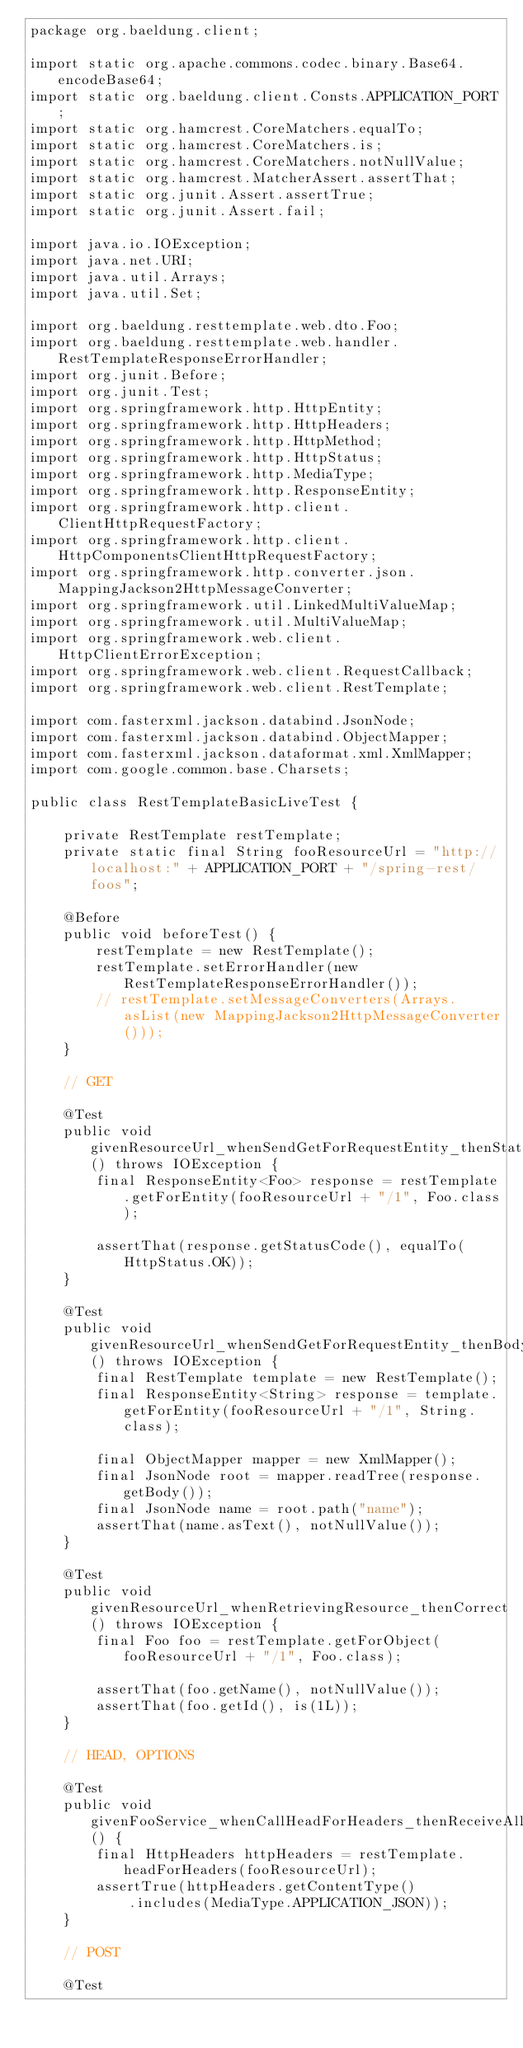<code> <loc_0><loc_0><loc_500><loc_500><_Java_>package org.baeldung.client;

import static org.apache.commons.codec.binary.Base64.encodeBase64;
import static org.baeldung.client.Consts.APPLICATION_PORT;
import static org.hamcrest.CoreMatchers.equalTo;
import static org.hamcrest.CoreMatchers.is;
import static org.hamcrest.CoreMatchers.notNullValue;
import static org.hamcrest.MatcherAssert.assertThat;
import static org.junit.Assert.assertTrue;
import static org.junit.Assert.fail;

import java.io.IOException;
import java.net.URI;
import java.util.Arrays;
import java.util.Set;

import org.baeldung.resttemplate.web.dto.Foo;
import org.baeldung.resttemplate.web.handler.RestTemplateResponseErrorHandler;
import org.junit.Before;
import org.junit.Test;
import org.springframework.http.HttpEntity;
import org.springframework.http.HttpHeaders;
import org.springframework.http.HttpMethod;
import org.springframework.http.HttpStatus;
import org.springframework.http.MediaType;
import org.springframework.http.ResponseEntity;
import org.springframework.http.client.ClientHttpRequestFactory;
import org.springframework.http.client.HttpComponentsClientHttpRequestFactory;
import org.springframework.http.converter.json.MappingJackson2HttpMessageConverter;
import org.springframework.util.LinkedMultiValueMap;
import org.springframework.util.MultiValueMap;
import org.springframework.web.client.HttpClientErrorException;
import org.springframework.web.client.RequestCallback;
import org.springframework.web.client.RestTemplate;

import com.fasterxml.jackson.databind.JsonNode;
import com.fasterxml.jackson.databind.ObjectMapper;
import com.fasterxml.jackson.dataformat.xml.XmlMapper;
import com.google.common.base.Charsets;

public class RestTemplateBasicLiveTest {

    private RestTemplate restTemplate;
    private static final String fooResourceUrl = "http://localhost:" + APPLICATION_PORT + "/spring-rest/foos";

    @Before
    public void beforeTest() {
        restTemplate = new RestTemplate();
        restTemplate.setErrorHandler(new RestTemplateResponseErrorHandler());
        // restTemplate.setMessageConverters(Arrays.asList(new MappingJackson2HttpMessageConverter()));
    }

    // GET

    @Test
    public void givenResourceUrl_whenSendGetForRequestEntity_thenStatusOk() throws IOException {
        final ResponseEntity<Foo> response = restTemplate.getForEntity(fooResourceUrl + "/1", Foo.class);

        assertThat(response.getStatusCode(), equalTo(HttpStatus.OK));
    }

    @Test
    public void givenResourceUrl_whenSendGetForRequestEntity_thenBodyCorrect() throws IOException {
        final RestTemplate template = new RestTemplate();
        final ResponseEntity<String> response = template.getForEntity(fooResourceUrl + "/1", String.class);

        final ObjectMapper mapper = new XmlMapper();
        final JsonNode root = mapper.readTree(response.getBody());
        final JsonNode name = root.path("name");
        assertThat(name.asText(), notNullValue());
    }

    @Test
    public void givenResourceUrl_whenRetrievingResource_thenCorrect() throws IOException {
        final Foo foo = restTemplate.getForObject(fooResourceUrl + "/1", Foo.class);

        assertThat(foo.getName(), notNullValue());
        assertThat(foo.getId(), is(1L));
    }

    // HEAD, OPTIONS

    @Test
    public void givenFooService_whenCallHeadForHeaders_thenReceiveAllHeadersForThatResource() {
        final HttpHeaders httpHeaders = restTemplate.headForHeaders(fooResourceUrl);
        assertTrue(httpHeaders.getContentType()
            .includes(MediaType.APPLICATION_JSON));
    }

    // POST

    @Test</code> 